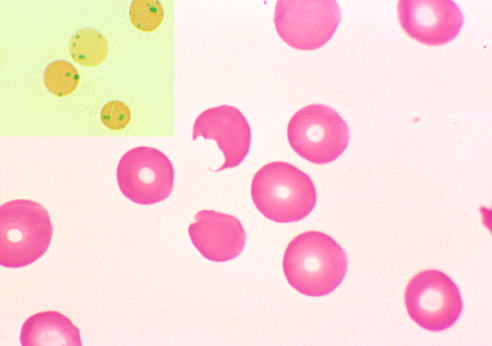re bite cells similar to the one in this smear produced?
Answer the question using a single word or phrase. Yes 